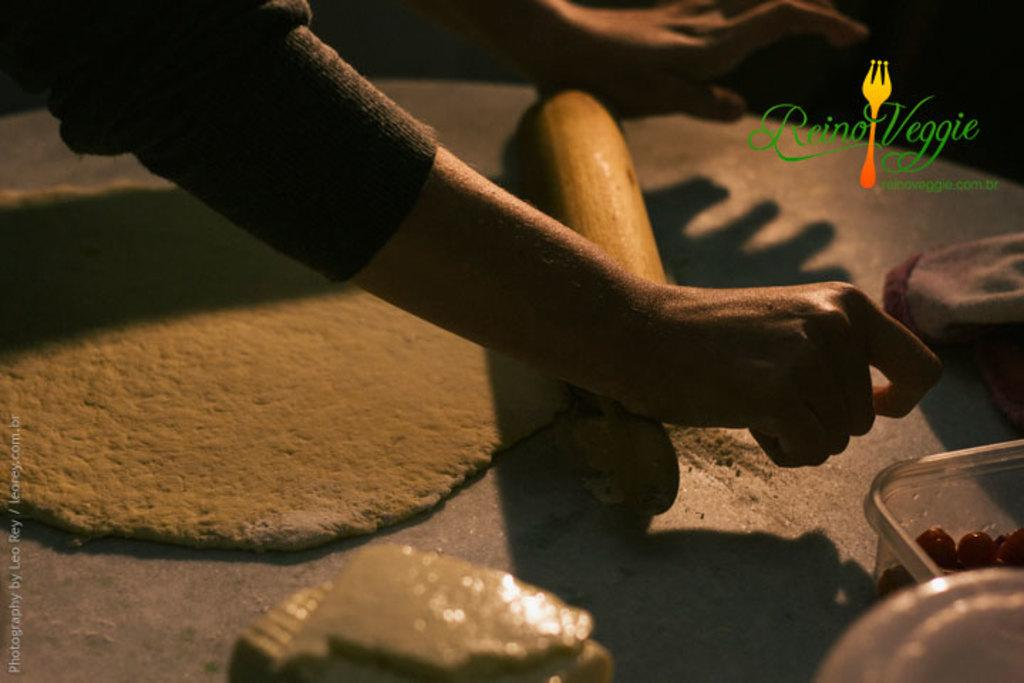What body parts are visible in the image? There are hands visible in the image. What type of item can be seen in the image? There is a food item in the image. What material are the objects made of in the image? There are plastic objects in the image. What else can be found on the surface in the image? There are other objects on the surface in the image. Is there any branding or identification in the image? Yes, there is a logo in the image. How does the pail help the throat in the image? There is no pail present in the image, and therefore no such assistance can be observed. 